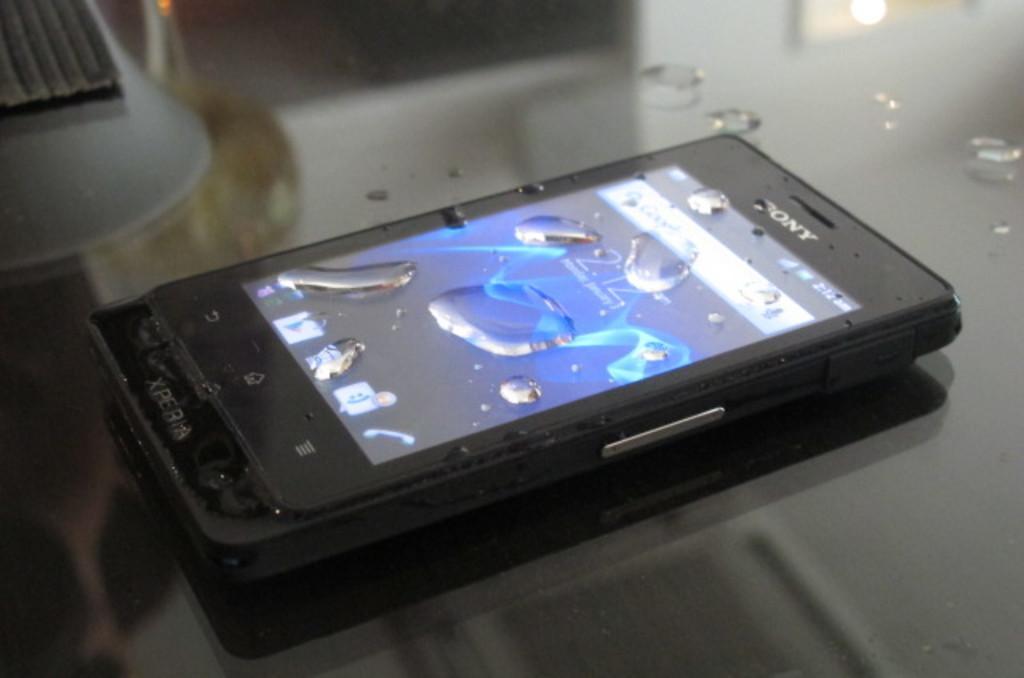Can you describe this image briefly? In this image there is a mobile phone on the glass table. On the phone there are droplets of water. On the left side top there is an object which is not clear. 